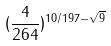<formula> <loc_0><loc_0><loc_500><loc_500>( \frac { 4 } { 2 6 4 } ) ^ { 1 0 / 1 9 7 - \sqrt { 9 } }</formula> 